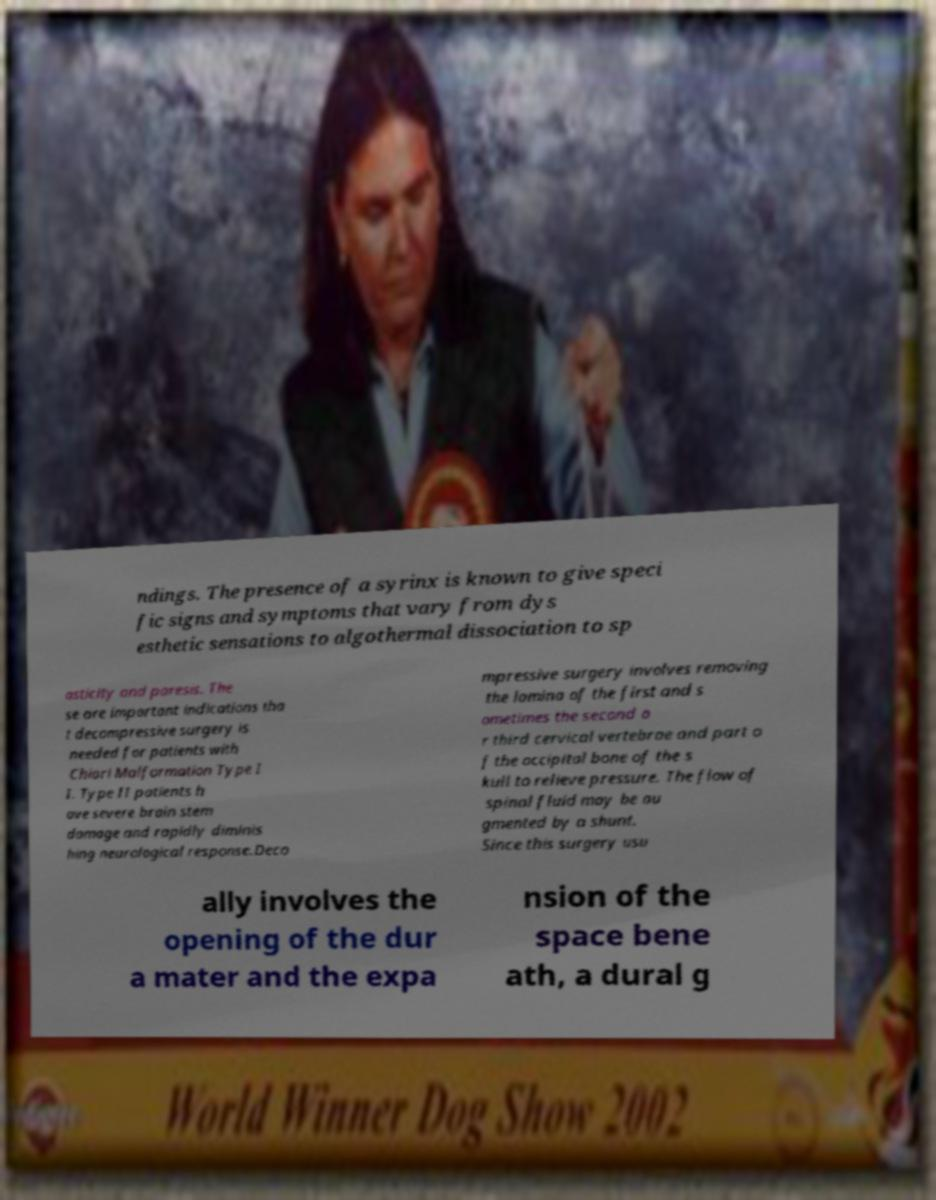I need the written content from this picture converted into text. Can you do that? ndings. The presence of a syrinx is known to give speci fic signs and symptoms that vary from dys esthetic sensations to algothermal dissociation to sp asticity and paresis. The se are important indications tha t decompressive surgery is needed for patients with Chiari Malformation Type I I. Type II patients h ave severe brain stem damage and rapidly diminis hing neurological response.Deco mpressive surgery involves removing the lamina of the first and s ometimes the second o r third cervical vertebrae and part o f the occipital bone of the s kull to relieve pressure. The flow of spinal fluid may be au gmented by a shunt. Since this surgery usu ally involves the opening of the dur a mater and the expa nsion of the space bene ath, a dural g 